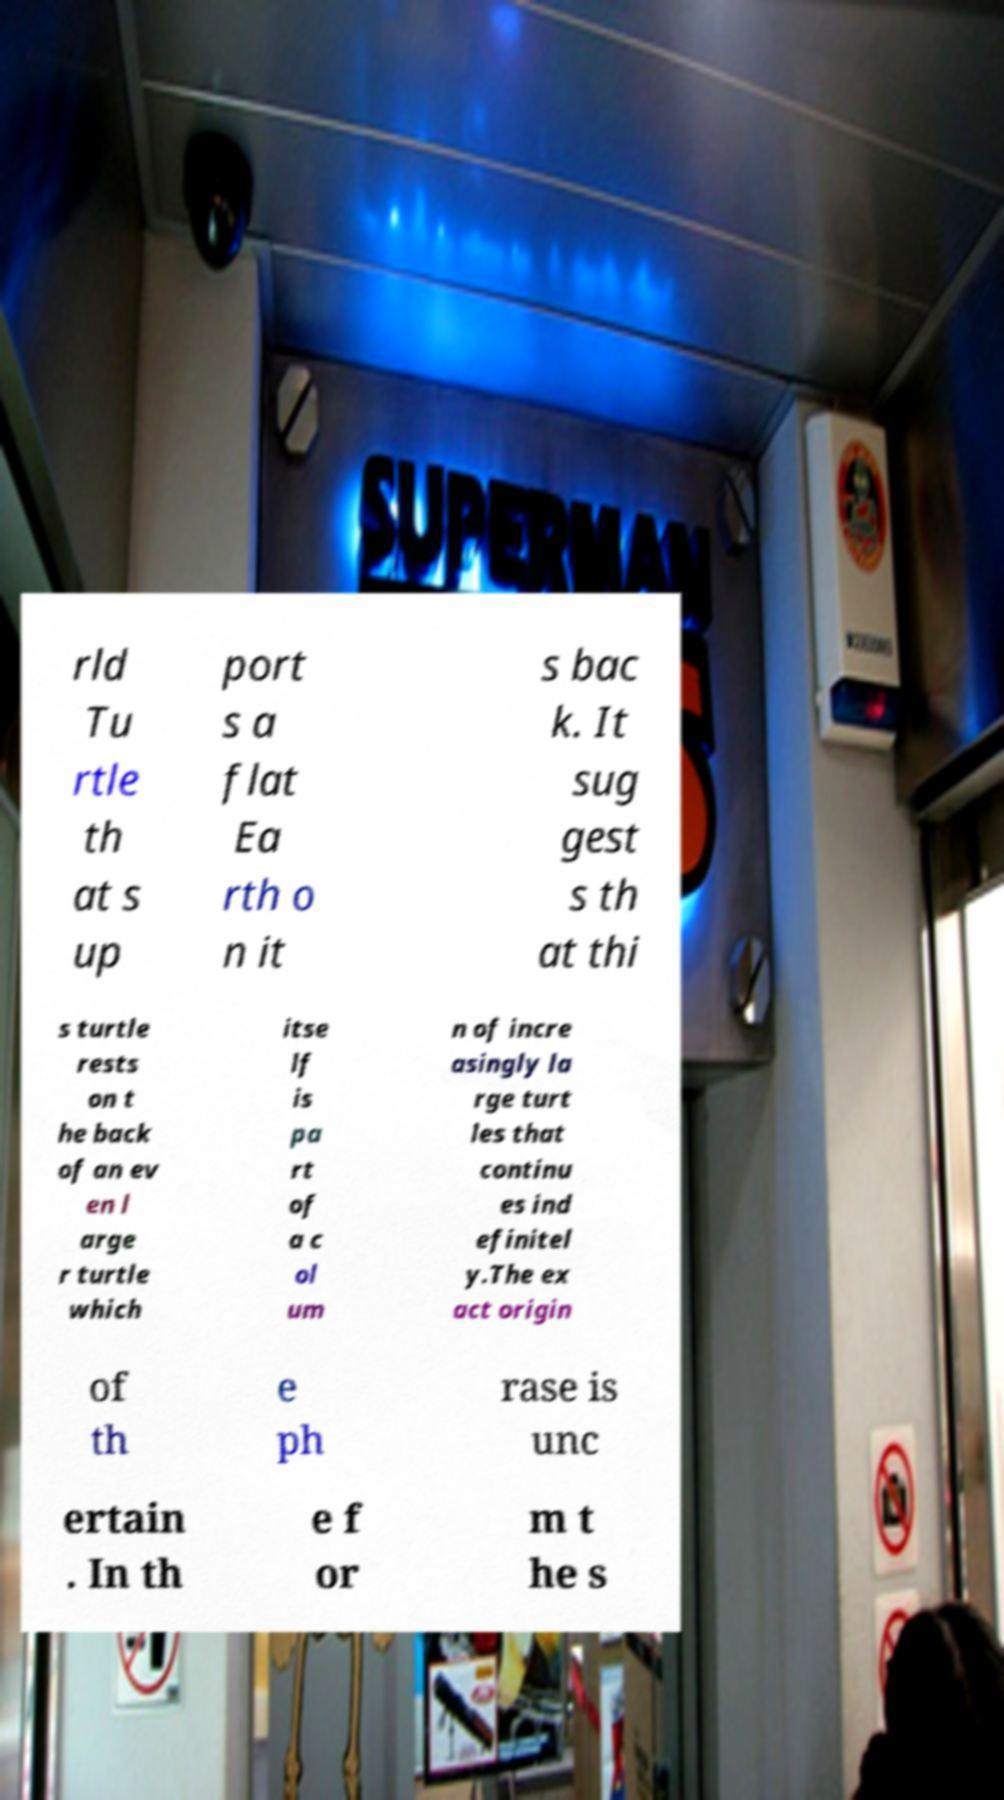I need the written content from this picture converted into text. Can you do that? rld Tu rtle th at s up port s a flat Ea rth o n it s bac k. It sug gest s th at thi s turtle rests on t he back of an ev en l arge r turtle which itse lf is pa rt of a c ol um n of incre asingly la rge turt les that continu es ind efinitel y.The ex act origin of th e ph rase is unc ertain . In th e f or m t he s 